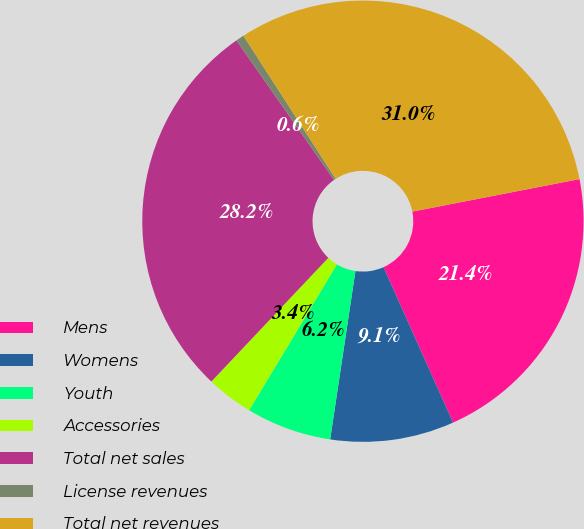Convert chart to OTSL. <chart><loc_0><loc_0><loc_500><loc_500><pie_chart><fcel>Mens<fcel>Womens<fcel>Youth<fcel>Accessories<fcel>Total net sales<fcel>License revenues<fcel>Total net revenues<nl><fcel>21.36%<fcel>9.07%<fcel>6.25%<fcel>3.43%<fcel>28.23%<fcel>0.61%<fcel>31.05%<nl></chart> 